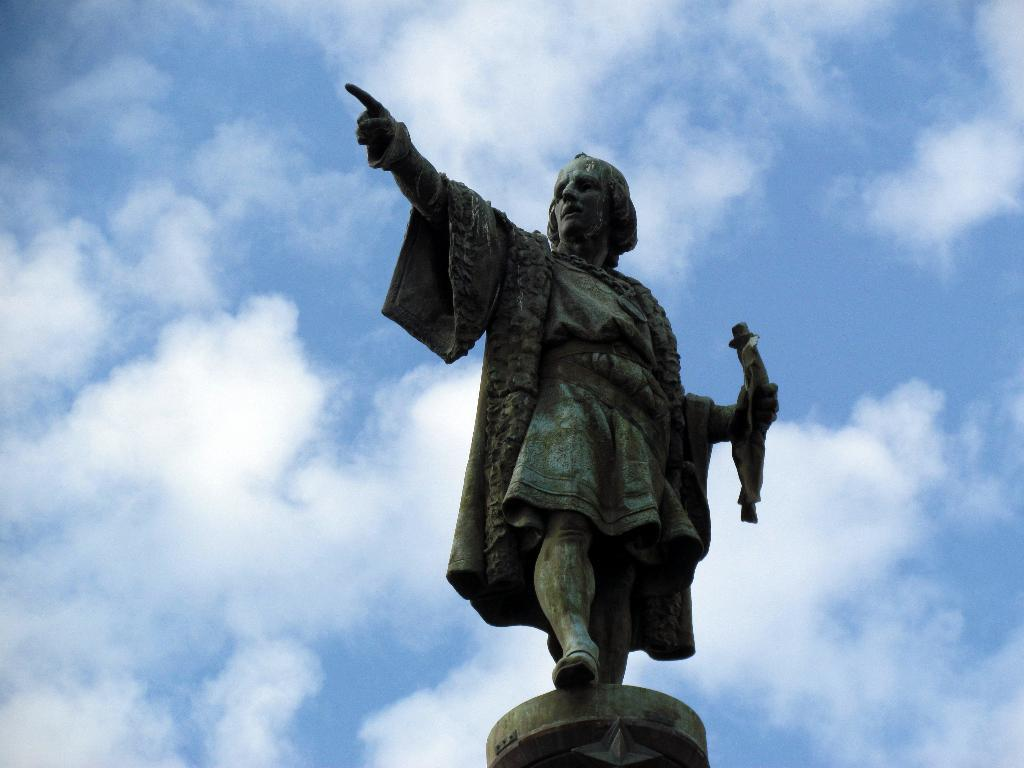What is the main subject in the center of the image? There is a statue in the center of the image. What can be seen in the background of the image? The sky is visible in the background of the image. Is there a swing in the image? No, there is no swing present in the image. 